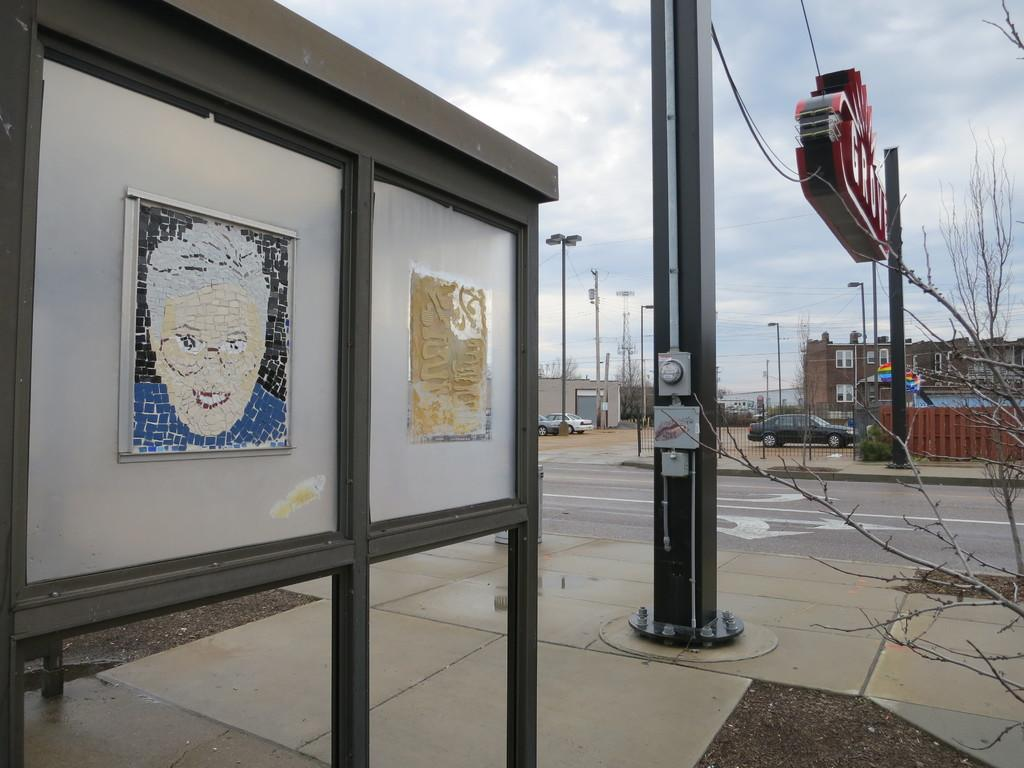What is the main object in the image? There is a board in the image. What type of natural elements can be seen in the image? There are trees in the image. What type of man-made structures are present in the image? There are buildings in the image. What other objects can be seen in the image? There are poles and stems of plants in the image. What is visible in the background of the image? The sky is visible in the background of the image. How many clocks are hanging on the trees in the image? There are no clocks hanging on the trees in the image. What type of calendar is visible on the board in the image? There is no calendar present on the board in the image. 